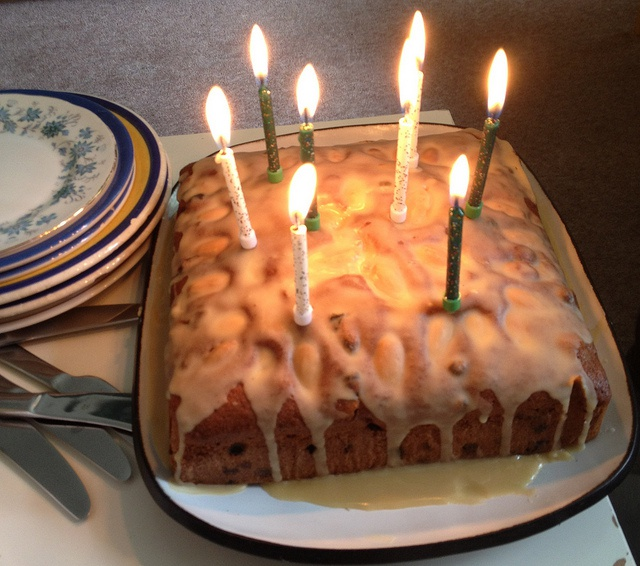Describe the objects in this image and their specific colors. I can see cake in black, orange, maroon, brown, and salmon tones, knife in black and gray tones, knife in black and gray tones, knife in black and gray tones, and knife in black, maroon, and brown tones in this image. 